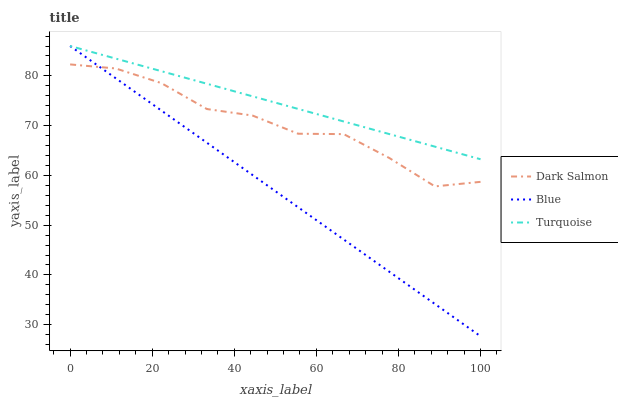Does Blue have the minimum area under the curve?
Answer yes or no. Yes. Does Turquoise have the maximum area under the curve?
Answer yes or no. Yes. Does Dark Salmon have the minimum area under the curve?
Answer yes or no. No. Does Dark Salmon have the maximum area under the curve?
Answer yes or no. No. Is Blue the smoothest?
Answer yes or no. Yes. Is Dark Salmon the roughest?
Answer yes or no. Yes. Is Turquoise the smoothest?
Answer yes or no. No. Is Turquoise the roughest?
Answer yes or no. No. Does Blue have the lowest value?
Answer yes or no. Yes. Does Dark Salmon have the lowest value?
Answer yes or no. No. Does Turquoise have the highest value?
Answer yes or no. Yes. Does Dark Salmon have the highest value?
Answer yes or no. No. Is Dark Salmon less than Turquoise?
Answer yes or no. Yes. Is Turquoise greater than Dark Salmon?
Answer yes or no. Yes. Does Blue intersect Dark Salmon?
Answer yes or no. Yes. Is Blue less than Dark Salmon?
Answer yes or no. No. Is Blue greater than Dark Salmon?
Answer yes or no. No. Does Dark Salmon intersect Turquoise?
Answer yes or no. No. 